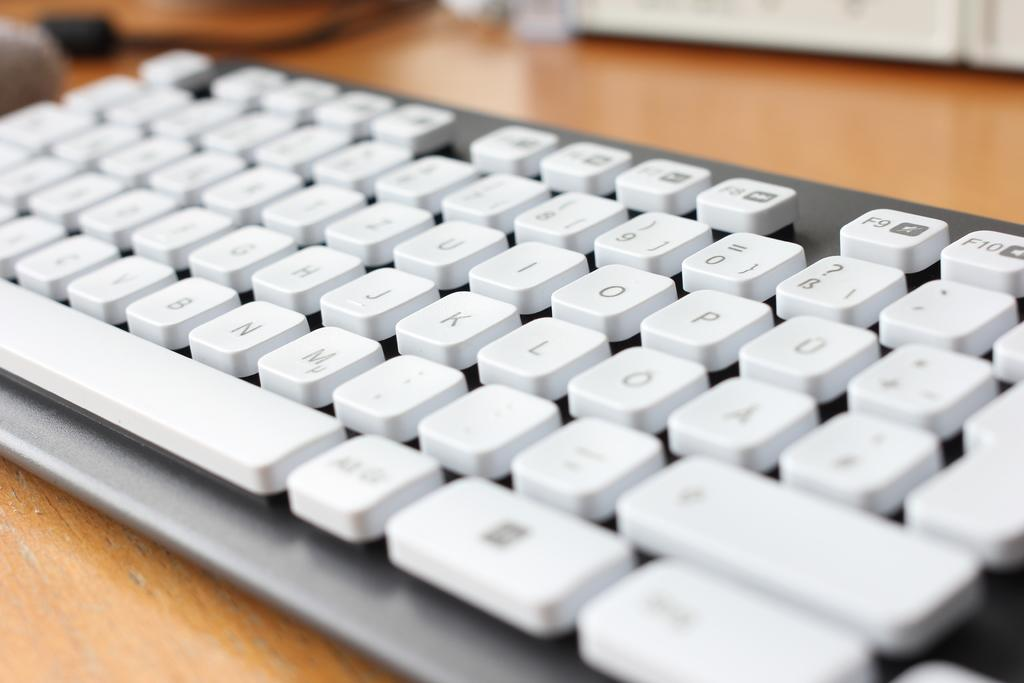What is the main object in the image? There is a keyboard in the image. What can be observed about the color of the items on the keyboard? The things on the keyboard are in white color. Where is the wren perched on the keyboard in the image? There is no wren present in the image. What type of suit is draped over the keyboard in the image? There is no suit present in the image. 